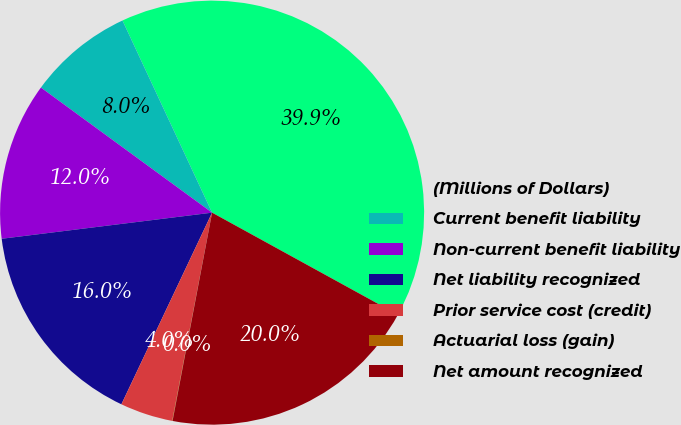Convert chart to OTSL. <chart><loc_0><loc_0><loc_500><loc_500><pie_chart><fcel>(Millions of Dollars)<fcel>Current benefit liability<fcel>Non-current benefit liability<fcel>Net liability recognized<fcel>Prior service cost (credit)<fcel>Actuarial loss (gain)<fcel>Net amount recognized<nl><fcel>39.94%<fcel>8.01%<fcel>12.01%<fcel>16.0%<fcel>4.02%<fcel>0.03%<fcel>19.99%<nl></chart> 